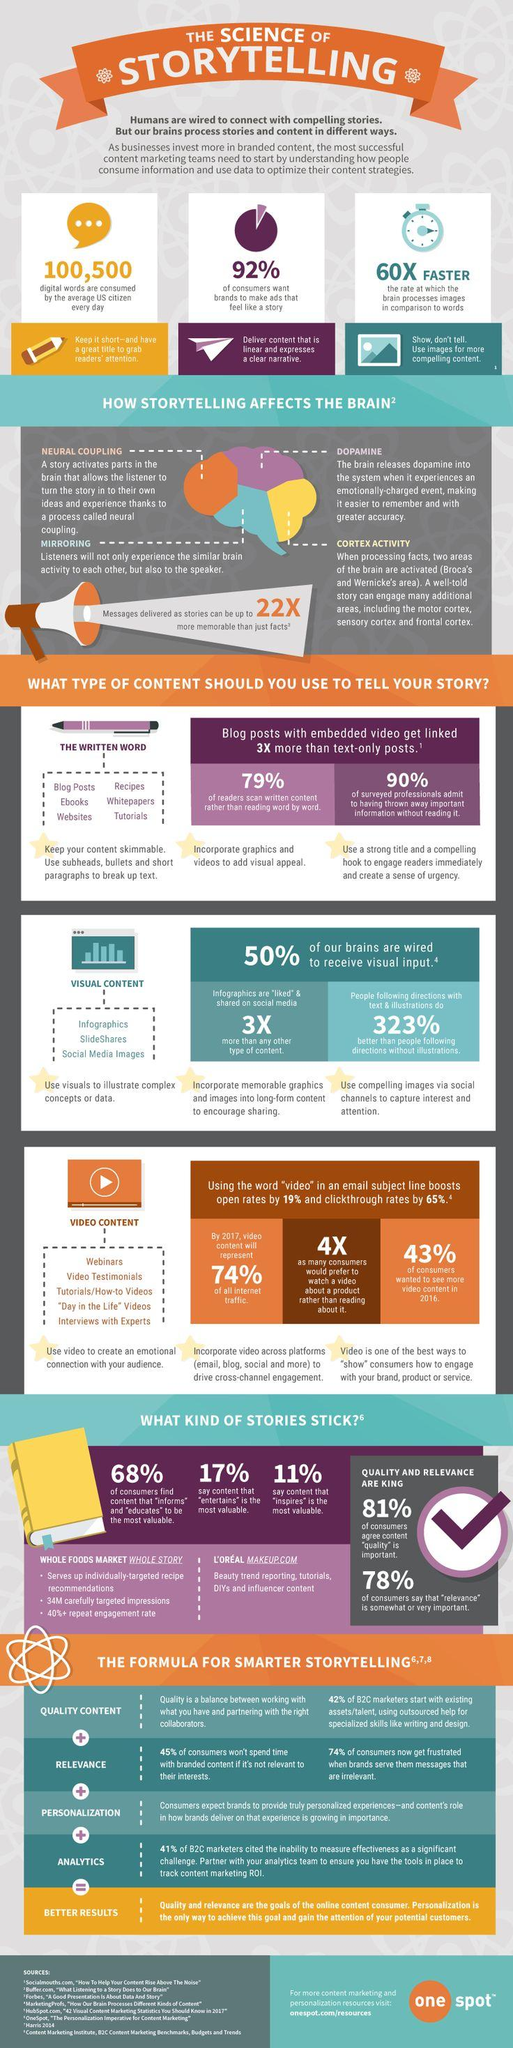Indicate a few pertinent items in this graphic. It is clear that video content is more likely to attract a larger audience than written or visual content. According to a survey, 68% of users prefer stories that convey a message. Dopamine is the hormone that is released by storytelling, the cortex, and the neural system. 